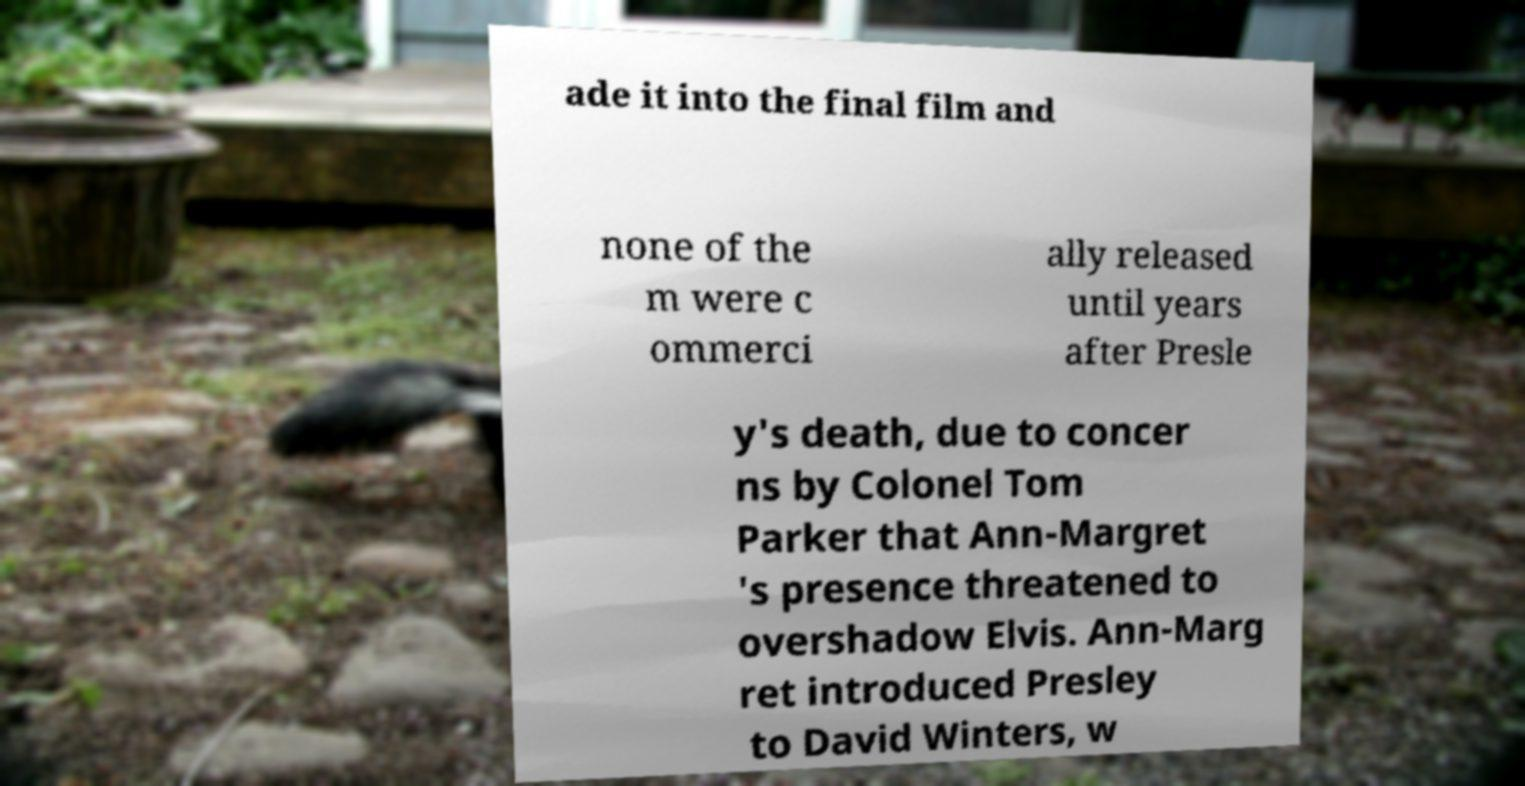Please identify and transcribe the text found in this image. ade it into the final film and none of the m were c ommerci ally released until years after Presle y's death, due to concer ns by Colonel Tom Parker that Ann-Margret 's presence threatened to overshadow Elvis. Ann-Marg ret introduced Presley to David Winters, w 